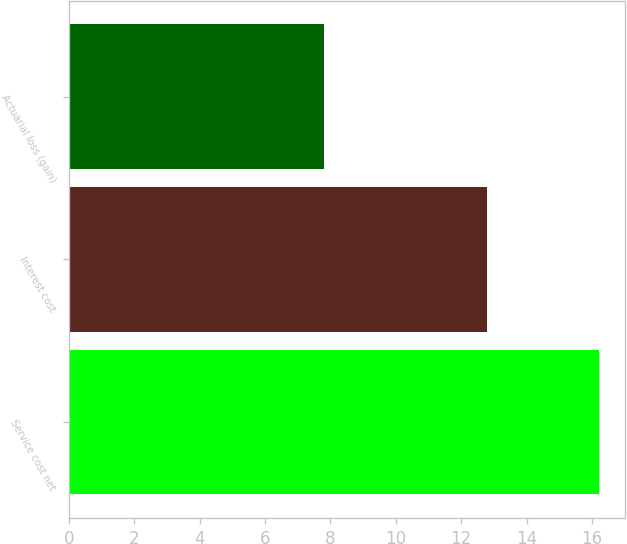Convert chart. <chart><loc_0><loc_0><loc_500><loc_500><bar_chart><fcel>Service cost net<fcel>Interest cost<fcel>Actuarial loss (gain)<nl><fcel>16.2<fcel>12.8<fcel>7.8<nl></chart> 